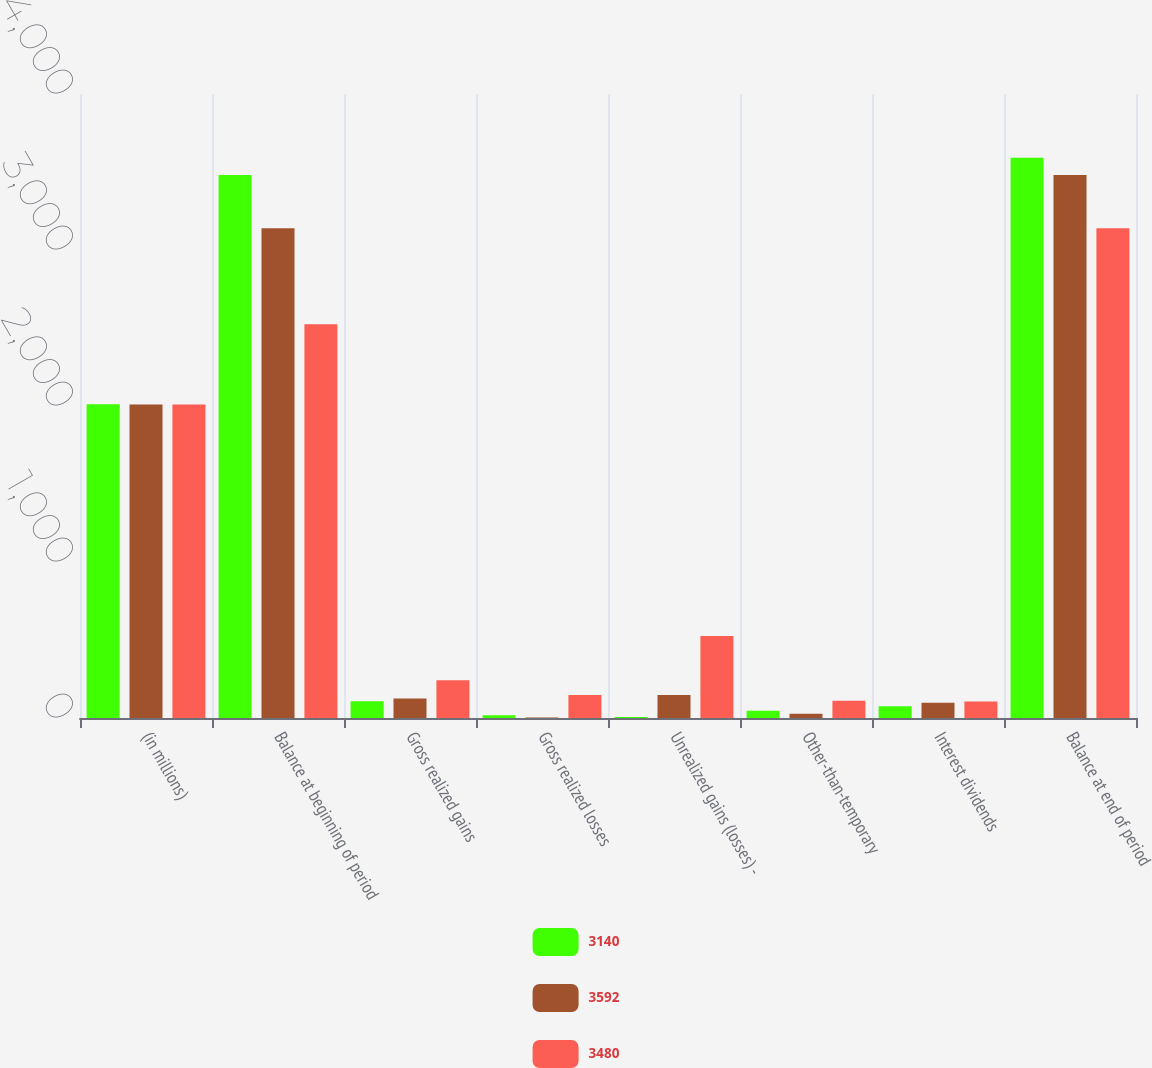<chart> <loc_0><loc_0><loc_500><loc_500><stacked_bar_chart><ecel><fcel>(in millions)<fcel>Balance at beginning of period<fcel>Gross realized gains<fcel>Gross realized losses<fcel>Unrealized gains (losses) -<fcel>Other-than-temporary<fcel>Interest dividends<fcel>Balance at end of period<nl><fcel>3140<fcel>2011<fcel>3480<fcel>108<fcel>17<fcel>7<fcel>47<fcel>75<fcel>3592<nl><fcel>3592<fcel>2010<fcel>3140<fcel>125<fcel>4<fcel>148<fcel>27<fcel>98<fcel>3480<nl><fcel>3480<fcel>2009<fcel>2524<fcel>242<fcel>147<fcel>526<fcel>111<fcel>106<fcel>3140<nl></chart> 